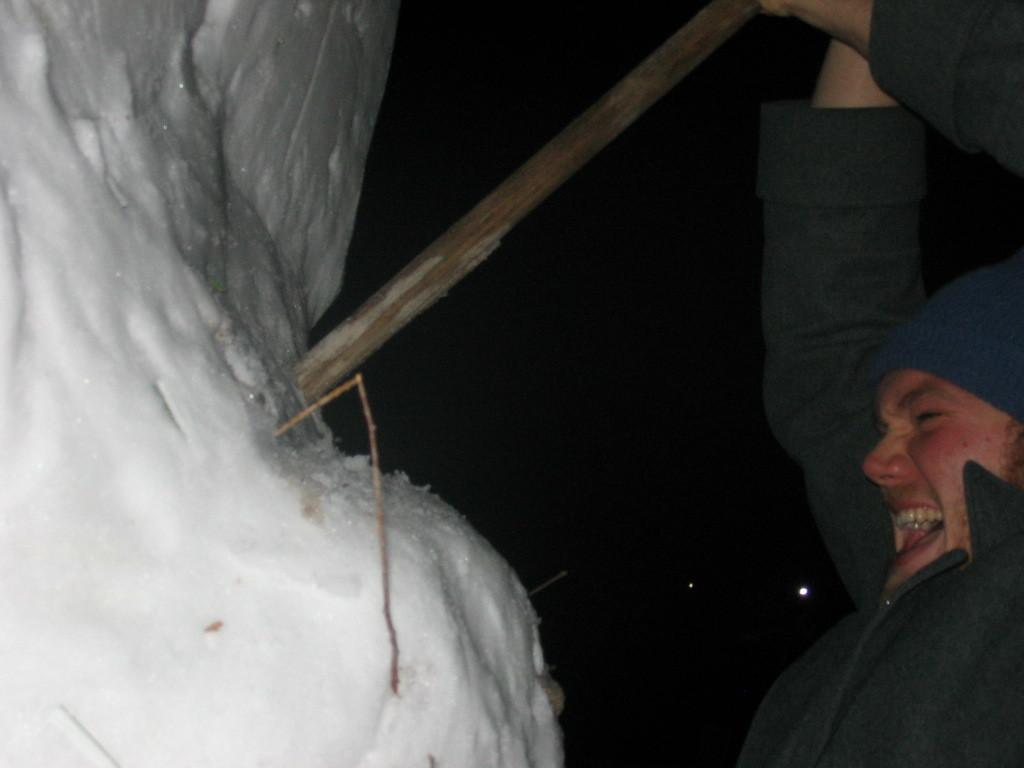Who is present in the image? There is a person in the image. What is the person wearing? The person is wearing a jacket and cap. What is the person holding in the image? The person is holding a stick. What is the person doing with the stick? The person is hitting a snow hill with the stick. How can you describe the background of the image? The background of the image is dark with some light far away. What type of adjustment can be seen in the market in the image? There is no market or adjustment present in the image; it features a person hitting a snow hill with a stick. What angle is the person using to hit the snow hill in the image? The angle at which the person is hitting the snow hill cannot be determined from the image alone. 